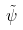<formula> <loc_0><loc_0><loc_500><loc_500>\tilde { \psi }</formula> 